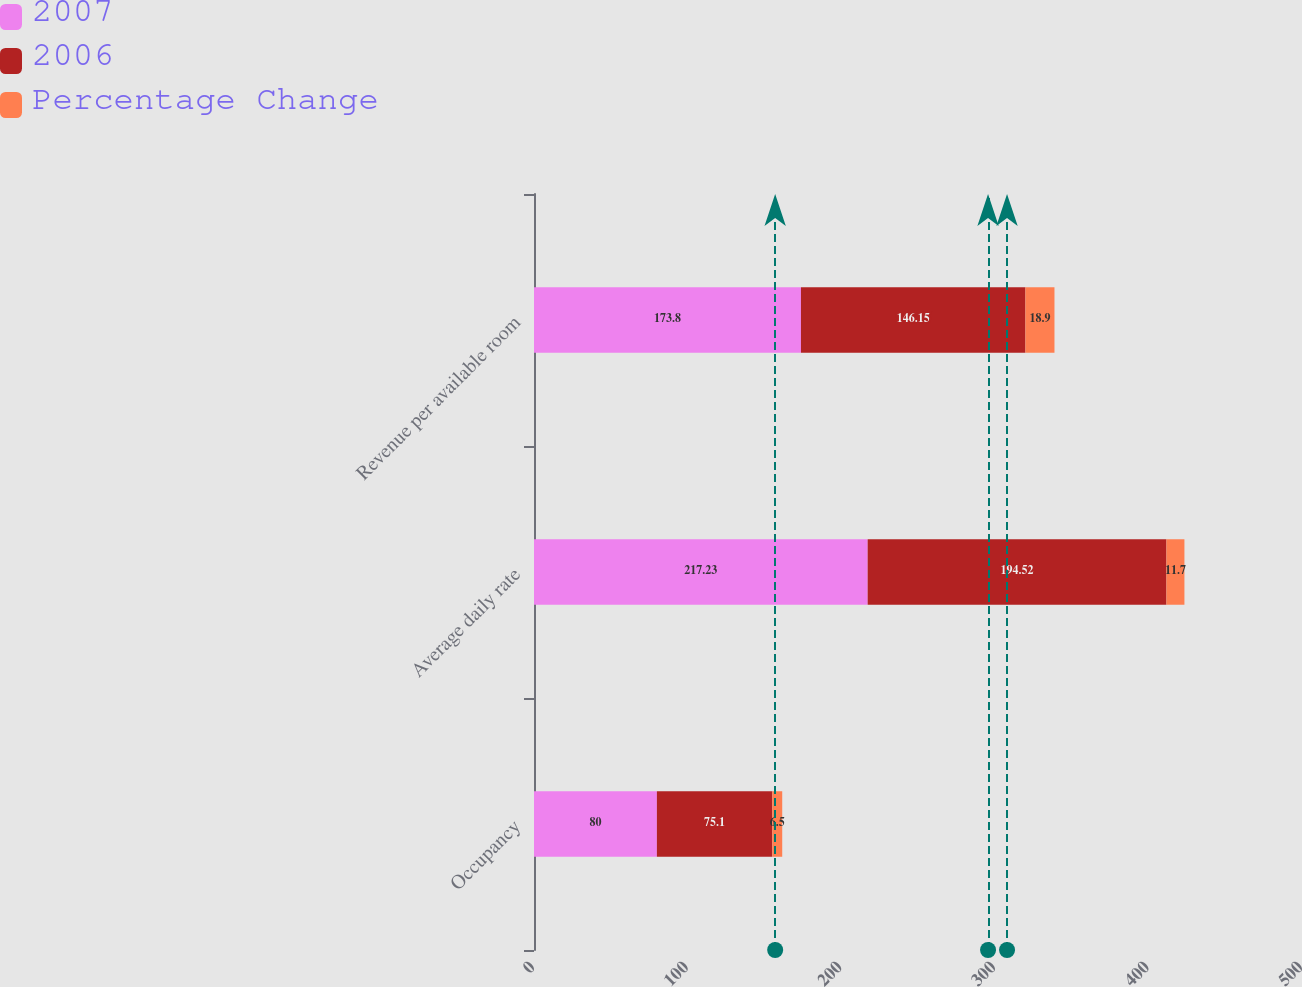Convert chart. <chart><loc_0><loc_0><loc_500><loc_500><stacked_bar_chart><ecel><fcel>Occupancy<fcel>Average daily rate<fcel>Revenue per available room<nl><fcel>2007<fcel>80<fcel>217.23<fcel>173.8<nl><fcel>2006<fcel>75.1<fcel>194.52<fcel>146.15<nl><fcel>Percentage Change<fcel>6.5<fcel>11.7<fcel>18.9<nl></chart> 